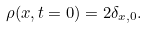<formula> <loc_0><loc_0><loc_500><loc_500>\rho ( { x } , t = 0 ) = 2 \delta _ { x , 0 } .</formula> 